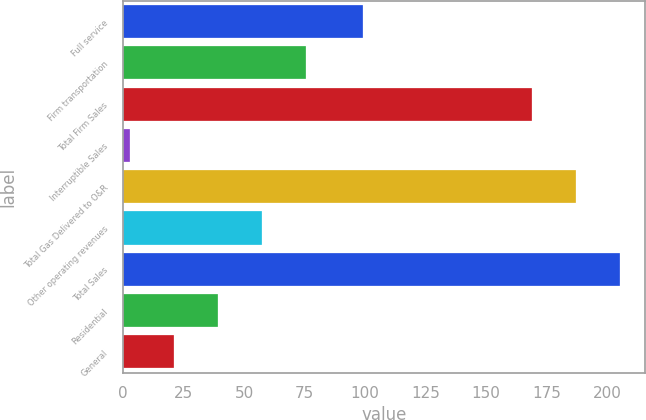Convert chart. <chart><loc_0><loc_0><loc_500><loc_500><bar_chart><fcel>Full service<fcel>Firm transportation<fcel>Total Firm Sales<fcel>Interruptible Sales<fcel>Total Gas Delivered to O&R<fcel>Other operating revenues<fcel>Total Sales<fcel>Residential<fcel>General<nl><fcel>99<fcel>75.4<fcel>169<fcel>3<fcel>187.1<fcel>57.3<fcel>205.2<fcel>39.2<fcel>21.1<nl></chart> 